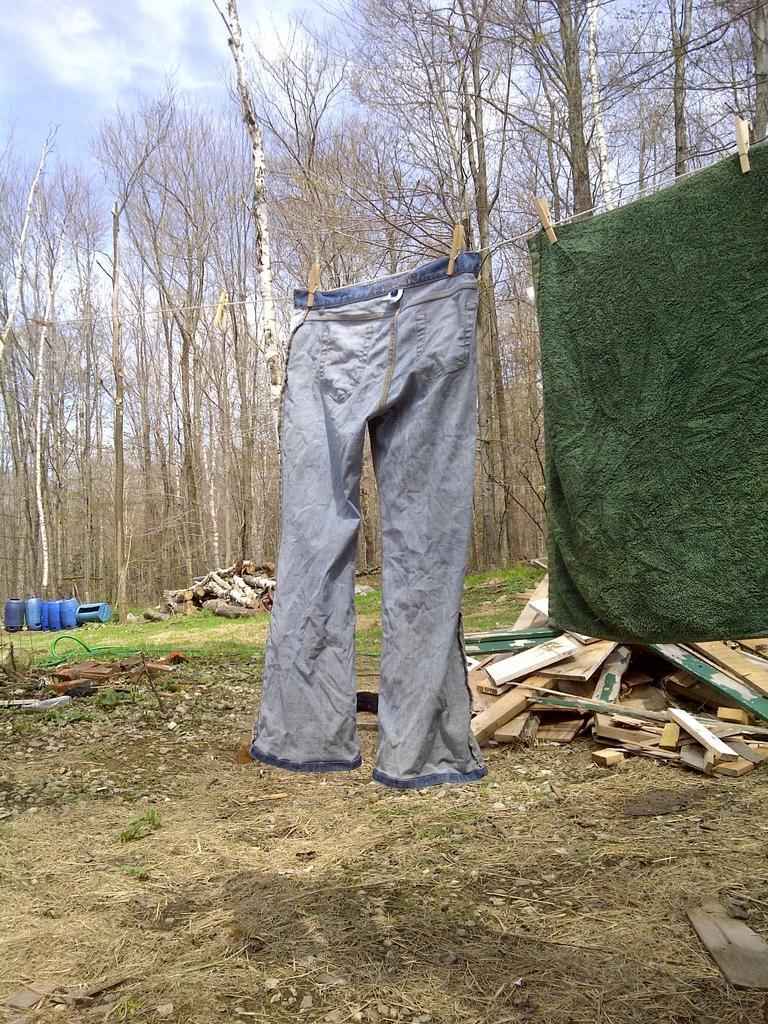Could you give a brief overview of what you see in this image? In this picture, we see a pant and a green color clothes are hanged along the rope to dry. Behind that, we see wooden sticks. At the bottom of the picture, we see small twigs. On the left side, we see blue color drums and wooden sticks. There are trees in the background. At the top of the picture, we see the sky. 